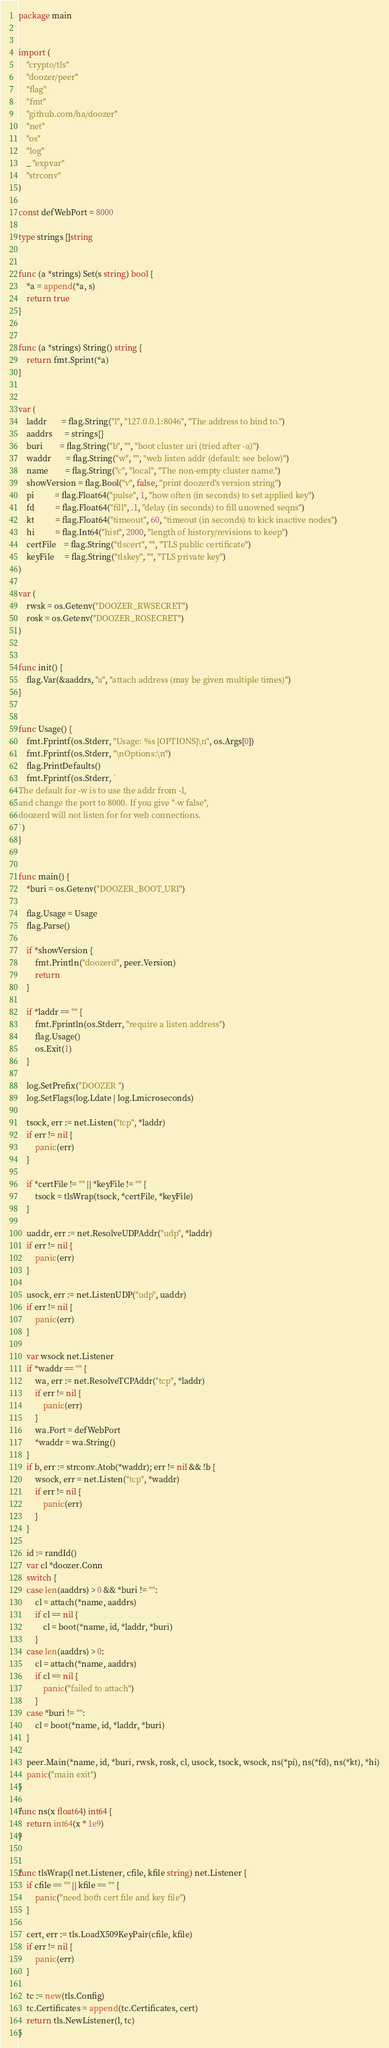Convert code to text. <code><loc_0><loc_0><loc_500><loc_500><_Go_>package main


import (
	"crypto/tls"
	"doozer/peer"
	"flag"
	"fmt"
	"github.com/ha/doozer"
	"net"
	"os"
	"log"
	_ "expvar"
	"strconv"
)

const defWebPort = 8000

type strings []string


func (a *strings) Set(s string) bool {
	*a = append(*a, s)
	return true
}


func (a *strings) String() string {
	return fmt.Sprint(*a)
}


var (
	laddr       = flag.String("l", "127.0.0.1:8046", "The address to bind to.")
	aaddrs      = strings{}
	buri        = flag.String("b", "", "boot cluster uri (tried after -a)")
	waddr       = flag.String("w", "", "web listen addr (default: see below)")
	name        = flag.String("c", "local", "The non-empty cluster name.")
	showVersion = flag.Bool("v", false, "print doozerd's version string")
	pi          = flag.Float64("pulse", 1, "how often (in seconds) to set applied key")
	fd          = flag.Float64("fill", .1, "delay (in seconds) to fill unowned seqns")
	kt          = flag.Float64("timeout", 60, "timeout (in seconds) to kick inactive nodes")
	hi          = flag.Int64("hist", 2000, "length of history/revisions to keep")
	certFile    = flag.String("tlscert", "", "TLS public certificate")
	keyFile     = flag.String("tlskey", "", "TLS private key")
)

var (
	rwsk = os.Getenv("DOOZER_RWSECRET")
	rosk = os.Getenv("DOOZER_ROSECRET")
)


func init() {
	flag.Var(&aaddrs, "a", "attach address (may be given multiple times)")
}


func Usage() {
	fmt.Fprintf(os.Stderr, "Usage: %s [OPTIONS]\n", os.Args[0])
	fmt.Fprintf(os.Stderr, "\nOptions:\n")
	flag.PrintDefaults()
	fmt.Fprintf(os.Stderr, `
The default for -w is to use the addr from -l,
and change the port to 8000. If you give "-w false",
doozerd will not listen for for web connections.
`)
}


func main() {
	*buri = os.Getenv("DOOZER_BOOT_URI")

	flag.Usage = Usage
	flag.Parse()

	if *showVersion {
		fmt.Println("doozerd", peer.Version)
		return
	}

	if *laddr == "" {
		fmt.Fprintln(os.Stderr, "require a listen address")
		flag.Usage()
		os.Exit(1)
	}

	log.SetPrefix("DOOZER ")
	log.SetFlags(log.Ldate | log.Lmicroseconds)

	tsock, err := net.Listen("tcp", *laddr)
	if err != nil {
		panic(err)
	}

	if *certFile != "" || *keyFile != "" {
		tsock = tlsWrap(tsock, *certFile, *keyFile)
	}

	uaddr, err := net.ResolveUDPAddr("udp", *laddr)
	if err != nil {
		panic(err)
	}

	usock, err := net.ListenUDP("udp", uaddr)
	if err != nil {
		panic(err)
	}

	var wsock net.Listener
	if *waddr == "" {
		wa, err := net.ResolveTCPAddr("tcp", *laddr)
		if err != nil {
			panic(err)
		}
		wa.Port = defWebPort
		*waddr = wa.String()
	}
	if b, err := strconv.Atob(*waddr); err != nil && !b {
		wsock, err = net.Listen("tcp", *waddr)
		if err != nil {
			panic(err)
		}
	}

	id := randId()
	var cl *doozer.Conn
	switch {
	case len(aaddrs) > 0 && *buri != "":
		cl = attach(*name, aaddrs)
		if cl == nil {
			cl = boot(*name, id, *laddr, *buri)
		}
	case len(aaddrs) > 0:
		cl = attach(*name, aaddrs)
		if cl == nil {
			panic("failed to attach")
		}
	case *buri != "":
		cl = boot(*name, id, *laddr, *buri)
	}

	peer.Main(*name, id, *buri, rwsk, rosk, cl, usock, tsock, wsock, ns(*pi), ns(*fd), ns(*kt), *hi)
	panic("main exit")
}

func ns(x float64) int64 {
	return int64(x * 1e9)
}


func tlsWrap(l net.Listener, cfile, kfile string) net.Listener {
	if cfile == "" || kfile == "" {
		panic("need both cert file and key file")
	}

	cert, err := tls.LoadX509KeyPair(cfile, kfile)
	if err != nil {
		panic(err)
	}

	tc := new(tls.Config)
	tc.Certificates = append(tc.Certificates, cert)
	return tls.NewListener(l, tc)
}
</code> 